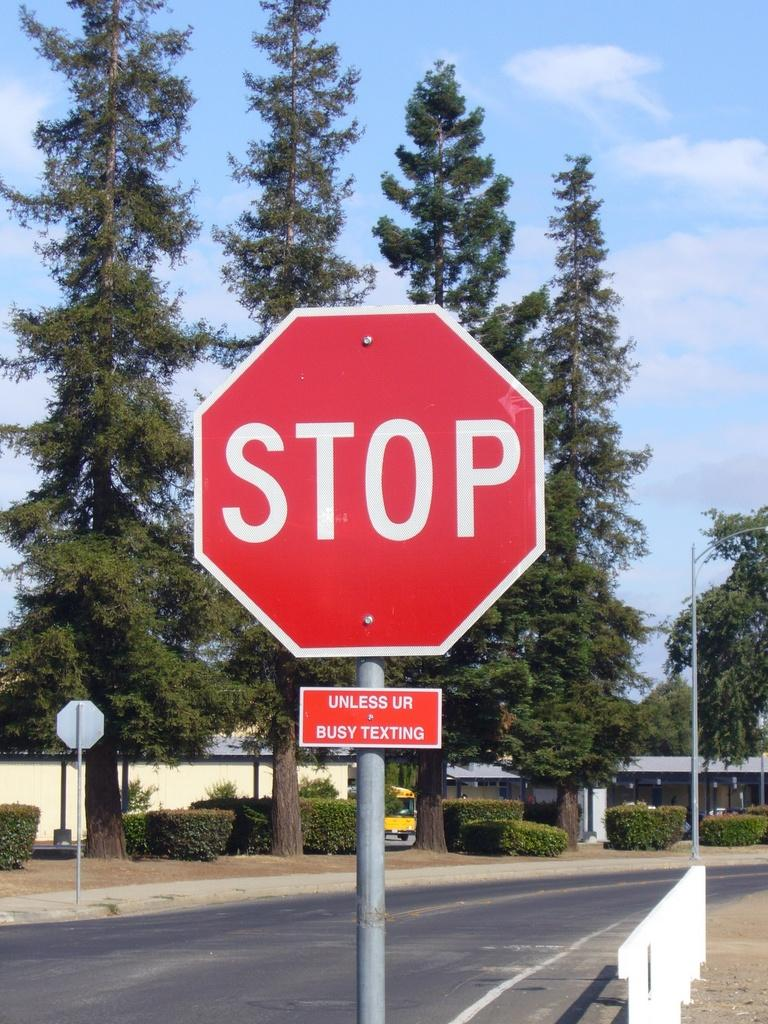<image>
Relay a brief, clear account of the picture shown. A stop sign has a small sign below it that says "unless ur busy texting". 